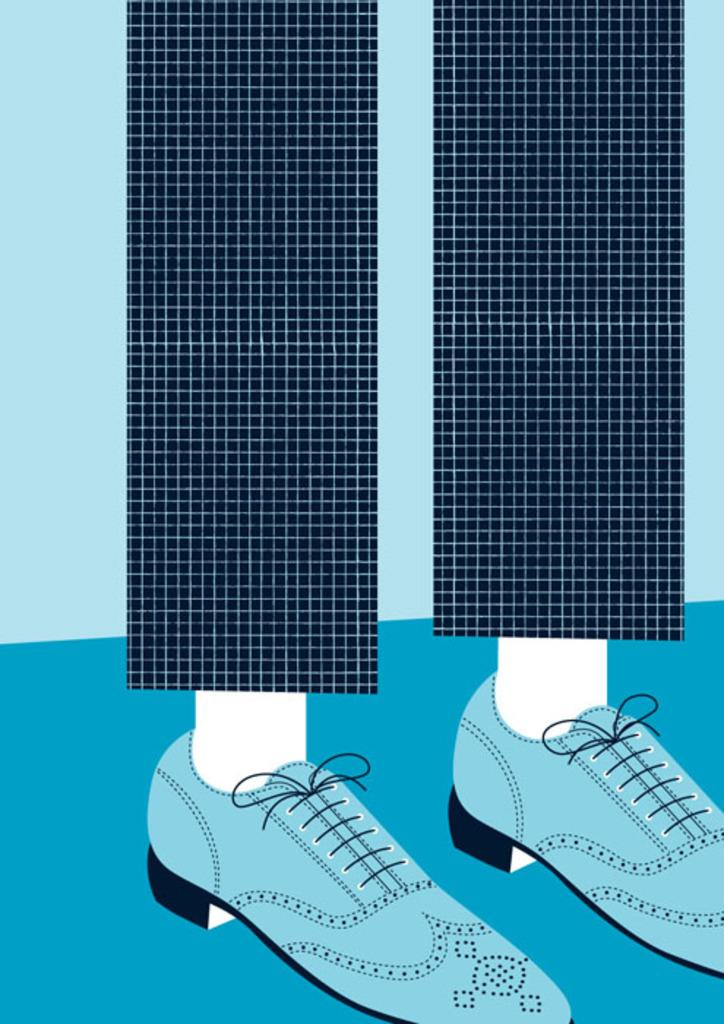What is the main subject of the painting in the image? The painting depicts a person's leg. What type of clothing is the person wearing on their leg? The person is wearing trousers. What type of footwear is the person wearing? The person is wearing shoes. What is the color of the ground in the painting? The ground in the painting is blue in color. Can you see any grapes in the painting? There are no grapes present in the painting; it depicts a person's leg and clothing. Is there a zoo visible in the painting? There is no zoo present in the painting; it is a close-up of a person's leg. 